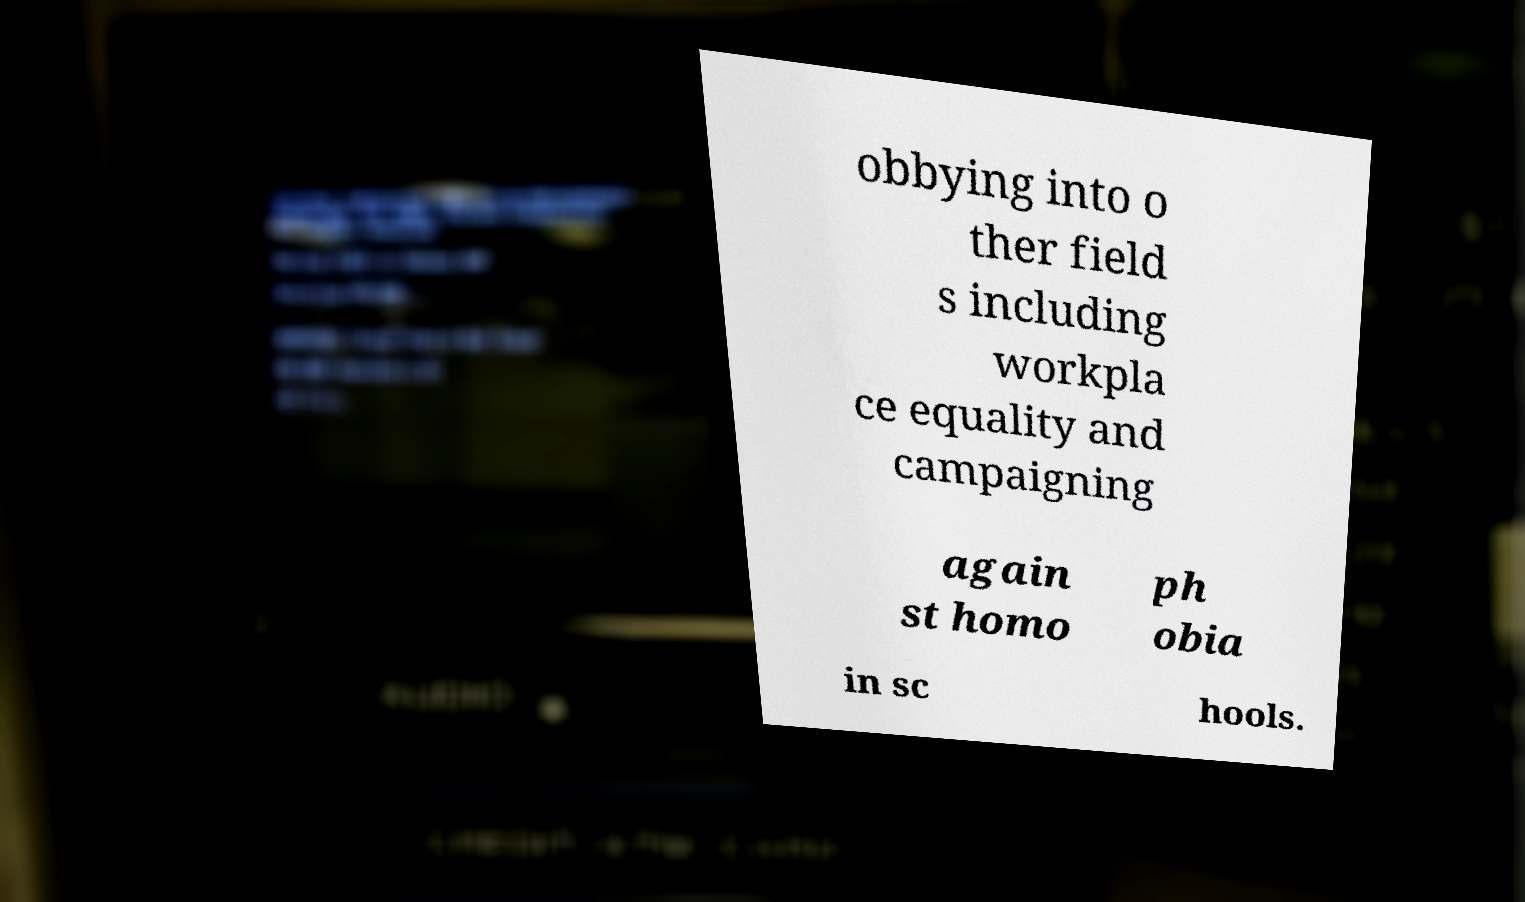Can you accurately transcribe the text from the provided image for me? obbying into o ther field s including workpla ce equality and campaigning again st homo ph obia in sc hools. 